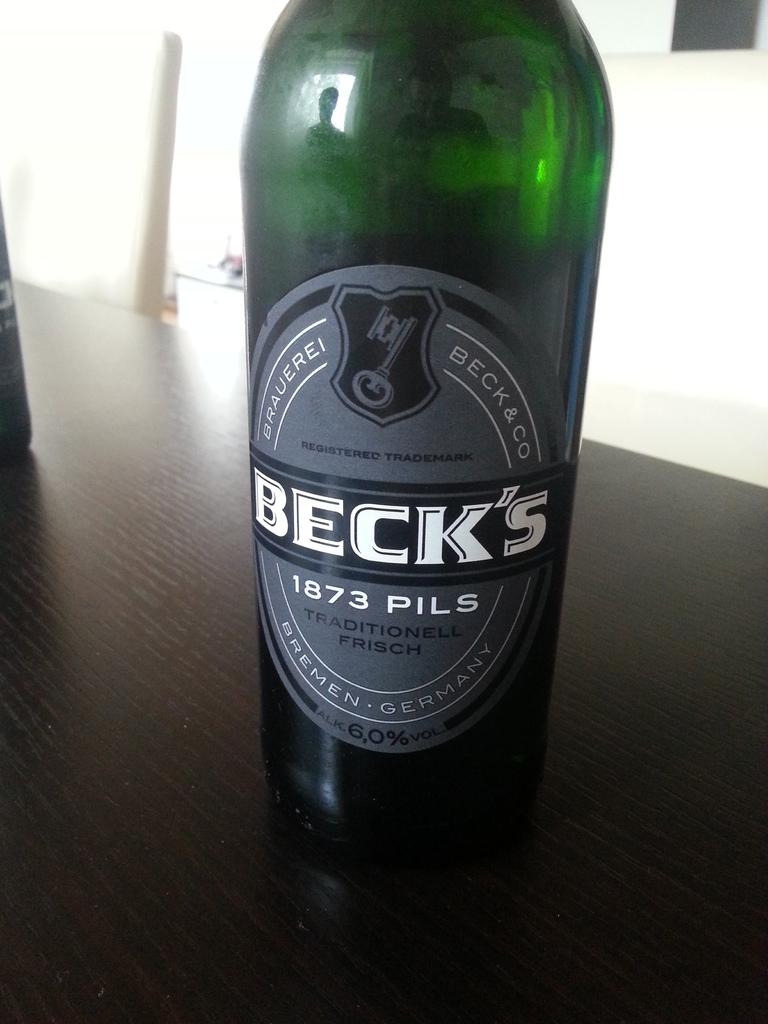<image>
Present a compact description of the photo's key features. A green bottle of German beer called Beck's that is sitting on a brown table. 